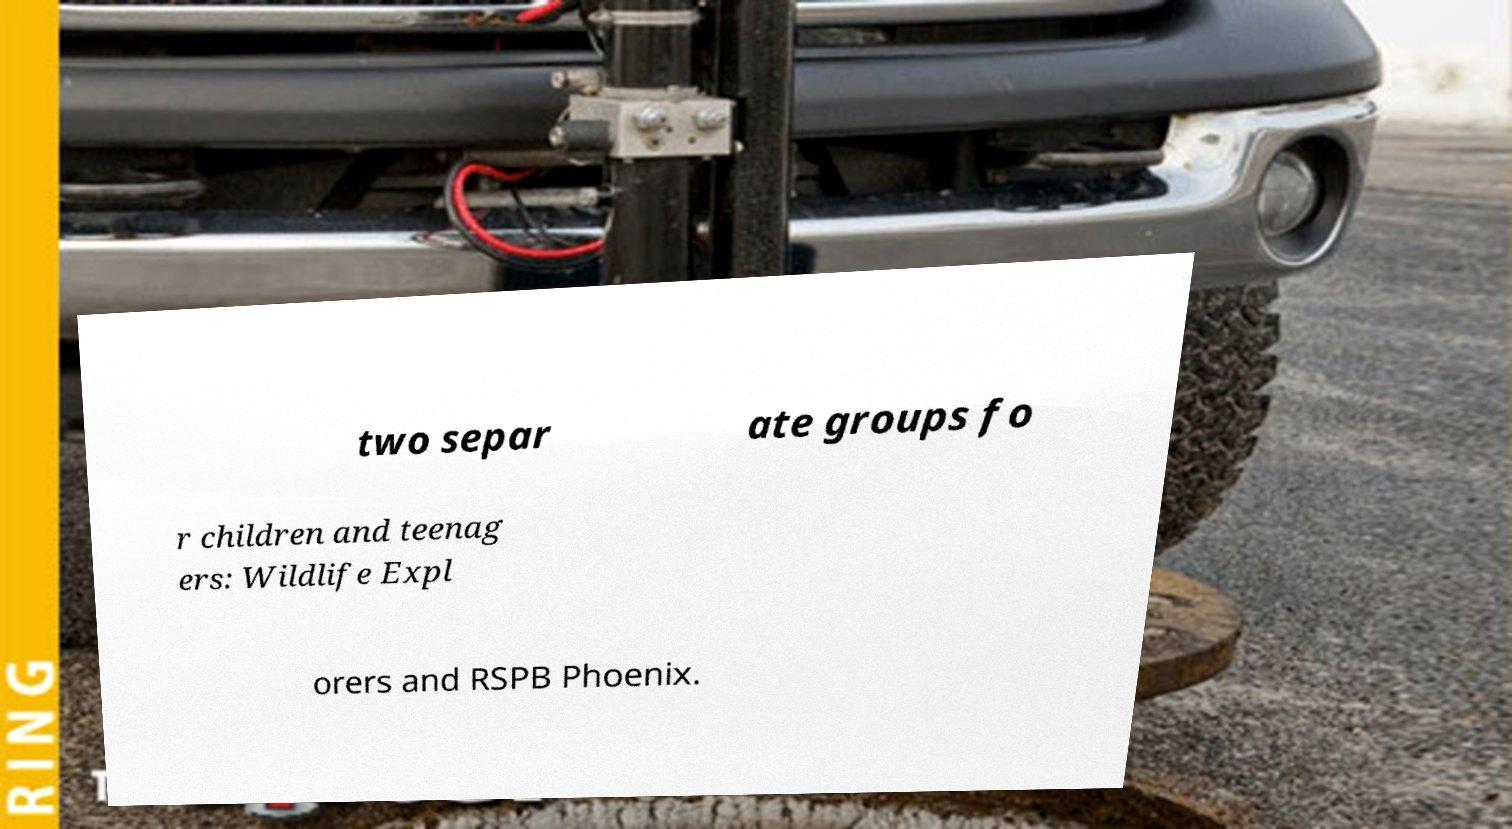Please identify and transcribe the text found in this image. two separ ate groups fo r children and teenag ers: Wildlife Expl orers and RSPB Phoenix. 